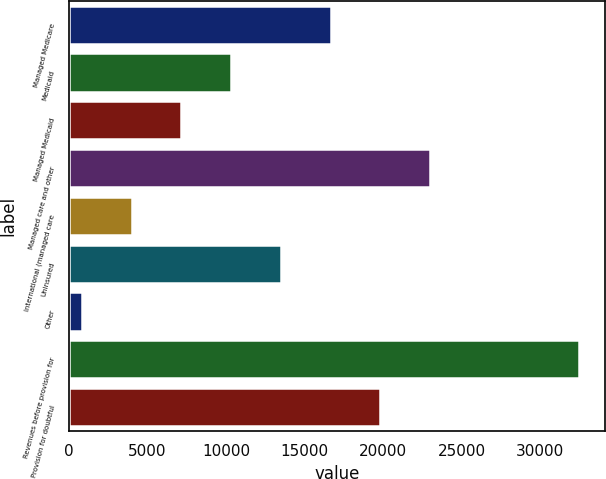Convert chart. <chart><loc_0><loc_0><loc_500><loc_500><bar_chart><fcel>Managed Medicare<fcel>Medicaid<fcel>Managed Medicaid<fcel>Managed care and other<fcel>International (managed care<fcel>Uninsured<fcel>Other<fcel>Revenues before provision for<fcel>Provision for doubtful<nl><fcel>16660<fcel>10321.6<fcel>7152.4<fcel>22998.4<fcel>3983.2<fcel>13490.8<fcel>814<fcel>32506<fcel>19829.2<nl></chart> 